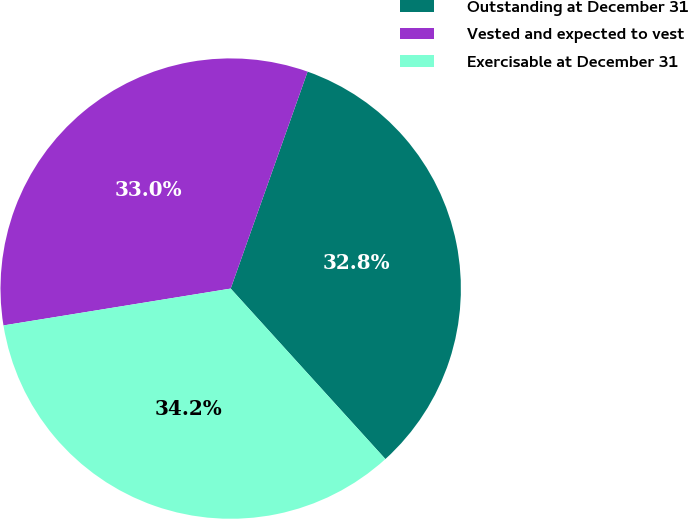Convert chart. <chart><loc_0><loc_0><loc_500><loc_500><pie_chart><fcel>Outstanding at December 31<fcel>Vested and expected to vest<fcel>Exercisable at December 31<nl><fcel>32.85%<fcel>32.98%<fcel>34.17%<nl></chart> 